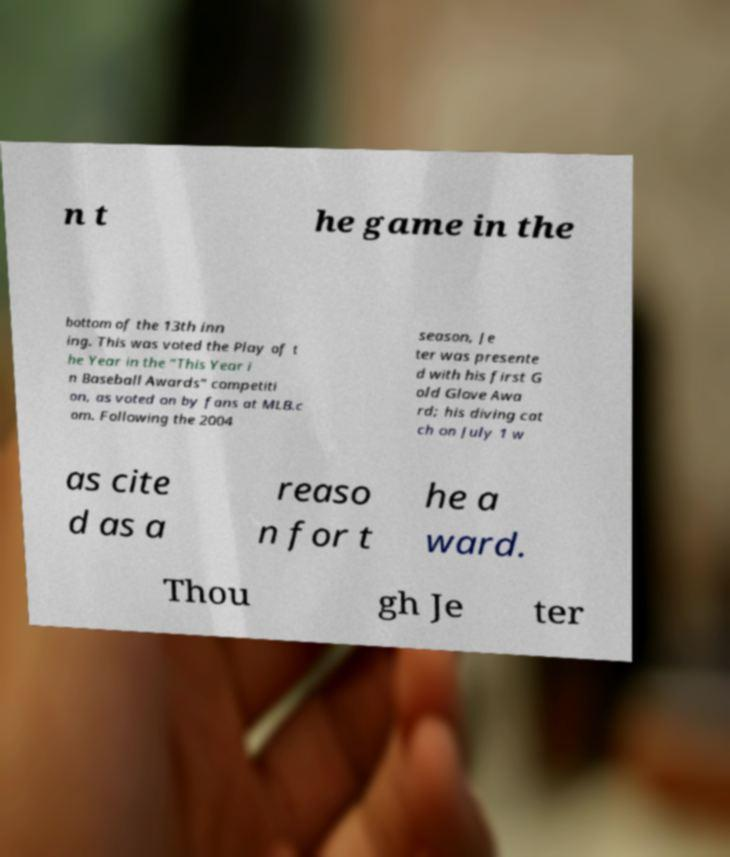There's text embedded in this image that I need extracted. Can you transcribe it verbatim? n t he game in the bottom of the 13th inn ing. This was voted the Play of t he Year in the "This Year i n Baseball Awards" competiti on, as voted on by fans at MLB.c om. Following the 2004 season, Je ter was presente d with his first G old Glove Awa rd; his diving cat ch on July 1 w as cite d as a reaso n for t he a ward. Thou gh Je ter 